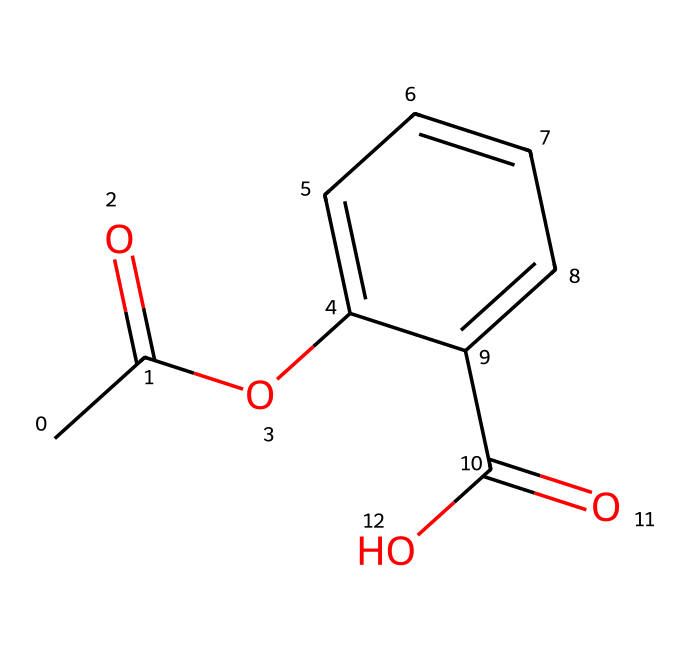What is the molecular formula of aspirin? To determine the molecular formula, we need to count the number of each type of atom in the SMILES representation. The structure indicates there are 9 carbons, 8 hydrogens, and 4 oxygens, which results in the molecular formula C9H8O4.
Answer: C9H8O4 How many oxygen atoms are in aspirin? By examining the SMILES representation, it shows that there are four 'O' symbols, indicating that there are four oxygen atoms present in the structure.
Answer: 4 What functional groups are present in aspirin? The SMILES indicates the presence of an ester (from the 'OC' and 'C(=O)O' parts) and a carboxylic acid (the 'C(=O)O'). Therefore, the functional groups are ester and carboxylic acid.
Answer: ester, carboxylic acid What type of solid is aspirin classified as? Aspirin is classified as an organic solid due to its carbon-containing structure and its classification as a small molecule that can crystallize.
Answer: organic solid How many rings are present in the structure of aspirin? In the SMILES representation, there is one ring noted by 'C1=CC=CC=C1', indicating that this structure contains one six-membered aromatic ring.
Answer: 1 What is the role of the acetyl group in aspirin's structure? The acetyl group in the structure (represented by 'CC(=O)O') contributes to aspirin's ability to inhibit the enzyme cyclooxygenase, playing a crucial role in its function as a pain reliever.
Answer: inhibit cyclooxygenase 